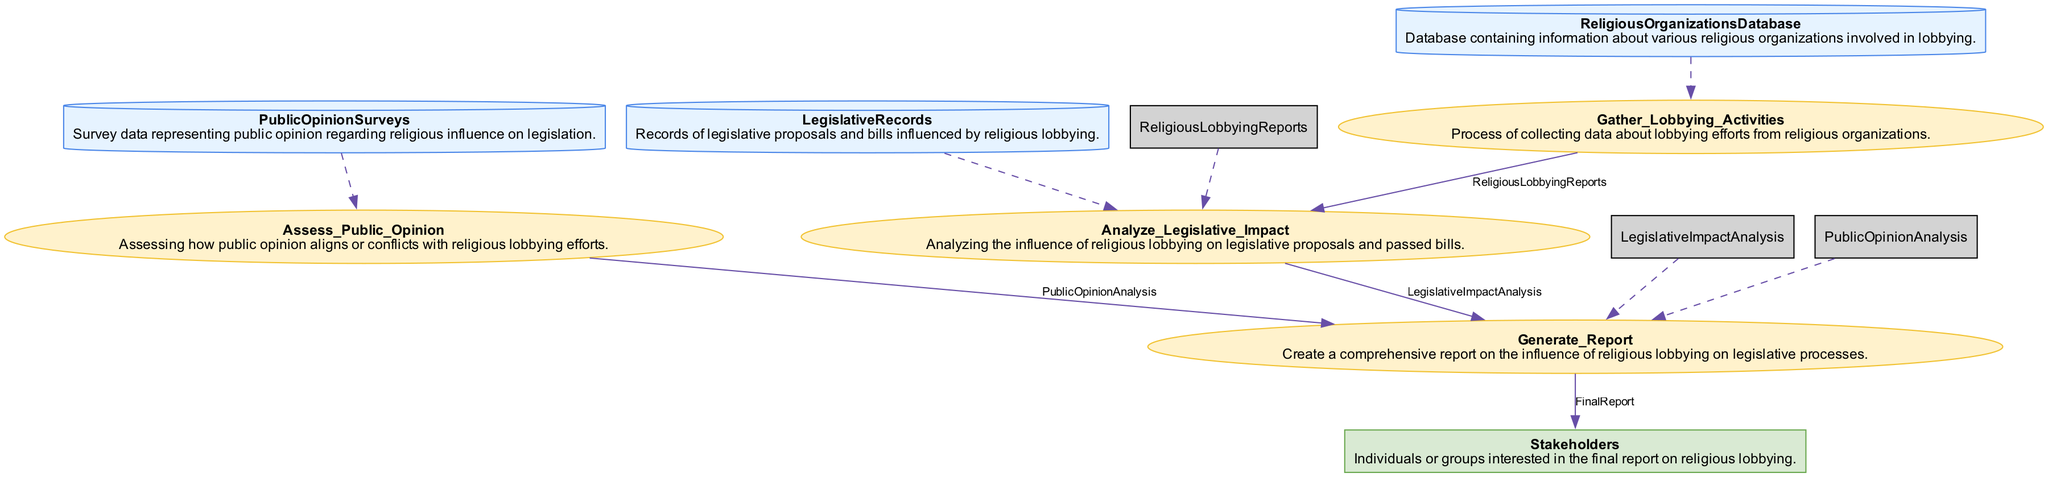What are the data stores present in the diagram? The diagram includes three data stores: "ReligiousOrganizationsDatabase," "LegislativeRecords," and "PublicOpinionSurveys."
Answer: ReligiousOrganizationsDatabase, LegislativeRecords, PublicOpinionSurveys How many processes are depicted in the diagram? The diagram shows four processes: "Gather_Lobbying_Activities," "Analyze_Legislative_Impact," "Assess_Public_Opinion," and "Generate_Report." Counting these processes gives a total of four.
Answer: 4 Which process takes "LegislativeRecords" as input? The only process that takes "LegislativeRecords" as an input is "Analyze_Legislative_Impact." This can be identified by examining the inputs of each process in the diagram.
Answer: Analyze_Legislative_Impact What is the output of the "Generate_Report" process? The "Generate_Report" process produces one output, which is named "FinalReport." This is explicitly mentioned as the output in the process section of the diagram.
Answer: FinalReport Which entity receives the "FinalReport"? The "FinalReport" is sent to "Stakeholders." This is indicated as the destination of the output in the data flow connections of the diagram.
Answer: Stakeholders How many data flows are shown in the diagram? The diagram contains four data flows: "ReligiousLobbyingReports," "LegislativeImpactAnalysis," "PublicOpinionAnalysis," and "FinalReport." Counting these provides the total number of data flows as four.
Answer: 4 What is the relationship between "Assess_Public_Opinion" and "Generate_Report"? The relationship is that "Assess_Public_Opinion" provides the "PublicOpinionAnalysis" output, which is used as one of the inputs for the "Generate_Report" process. This connection shows how public opinion analysis feeds into the overall report generation.
Answer: "Assess_Public_Opinion" provides input to "Generate_Report." Which data store is the source for the "LegislativeImpactAnalysis"? The "LegislativeImpactAnalysis" process takes inputs from two sources: "LegislativeRecords" and "ReligiousLobbyingReports." Observing the inputs for this process confirms this information is correct.
Answer: LegislativeRecords, ReligiousLobbyingReports What is the primary purpose of the "Gather_Lobbying_Activities" process? The primary purpose of the "Gather_Lobbying_Activities" process is to collect data about lobbying efforts from religious organizations, as stated in its description in the diagram.
Answer: Collect data about lobbying efforts 